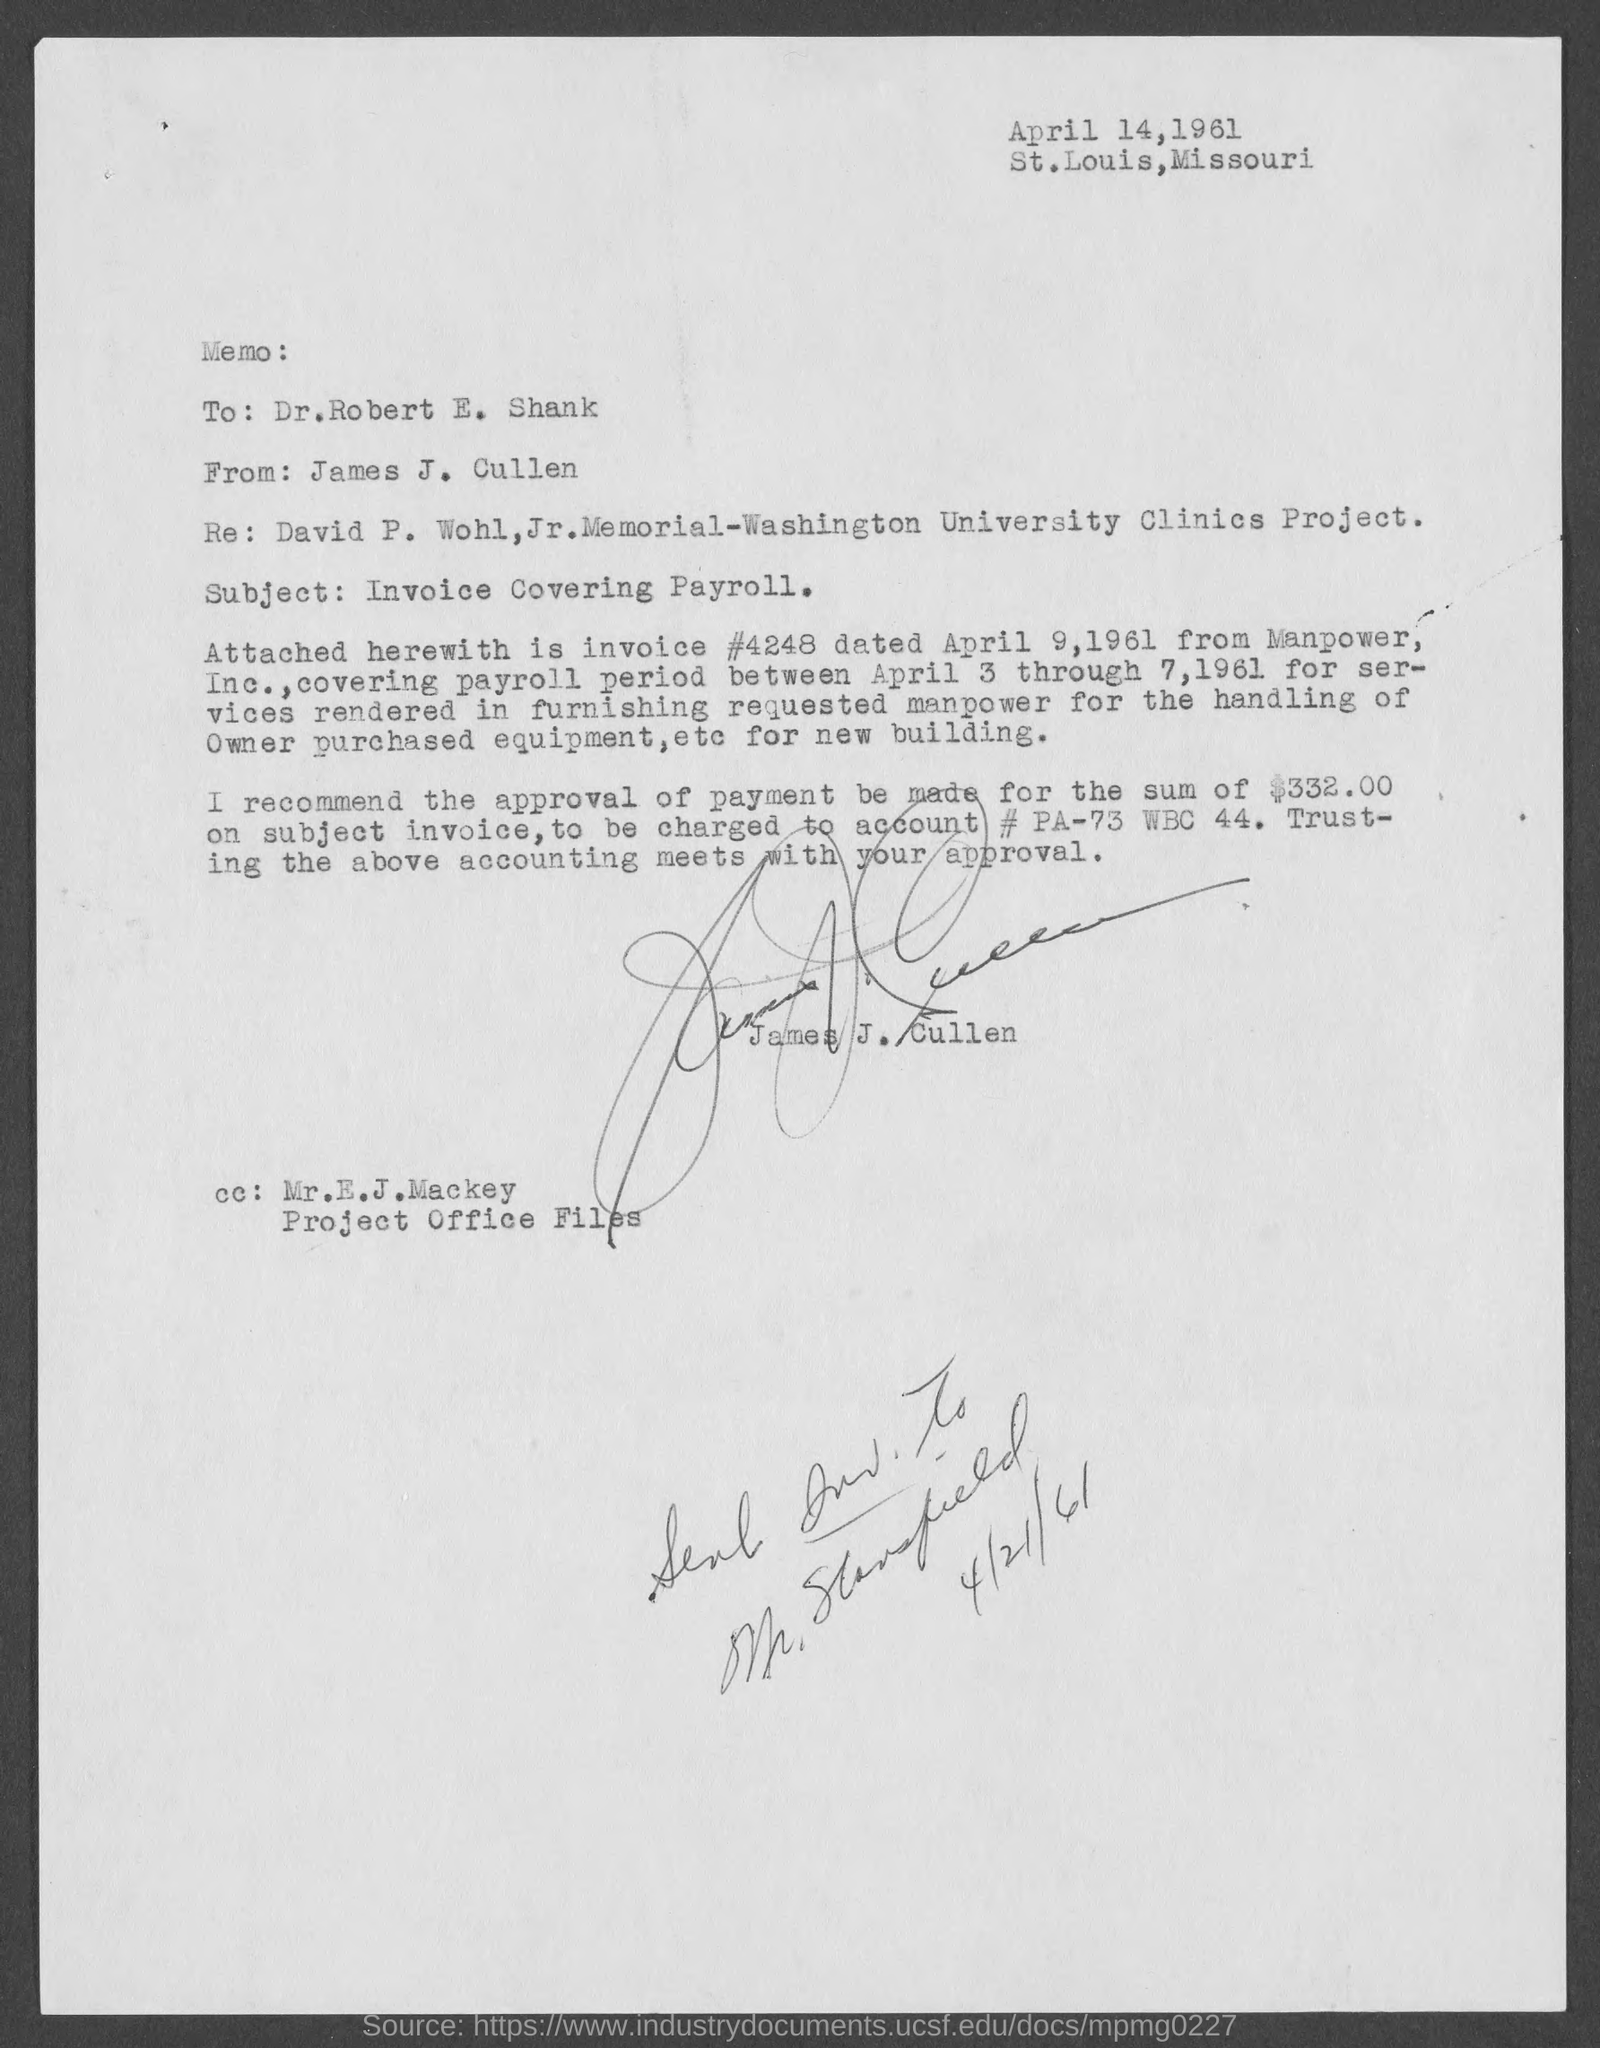When is the document dated?
Provide a succinct answer. April 14, 1961. From whom is the document?
Provide a succinct answer. James J. Cullen. What is the subject of the document?
Give a very brief answer. Invoice Covering Payroll. What is the invoice number?
Keep it short and to the point. 4248. When is the invoice dated?
Offer a terse response. April 9, 1961. From whom is the invoice?
Offer a very short reply. Manpower, Inc. What is the covering payroll period?
Your answer should be very brief. Between april 3 through 7, 1961. What is the payment amount to be made?
Give a very brief answer. $332.00. What is the account number specified?
Ensure brevity in your answer.  Pa-73 wbc 44. 